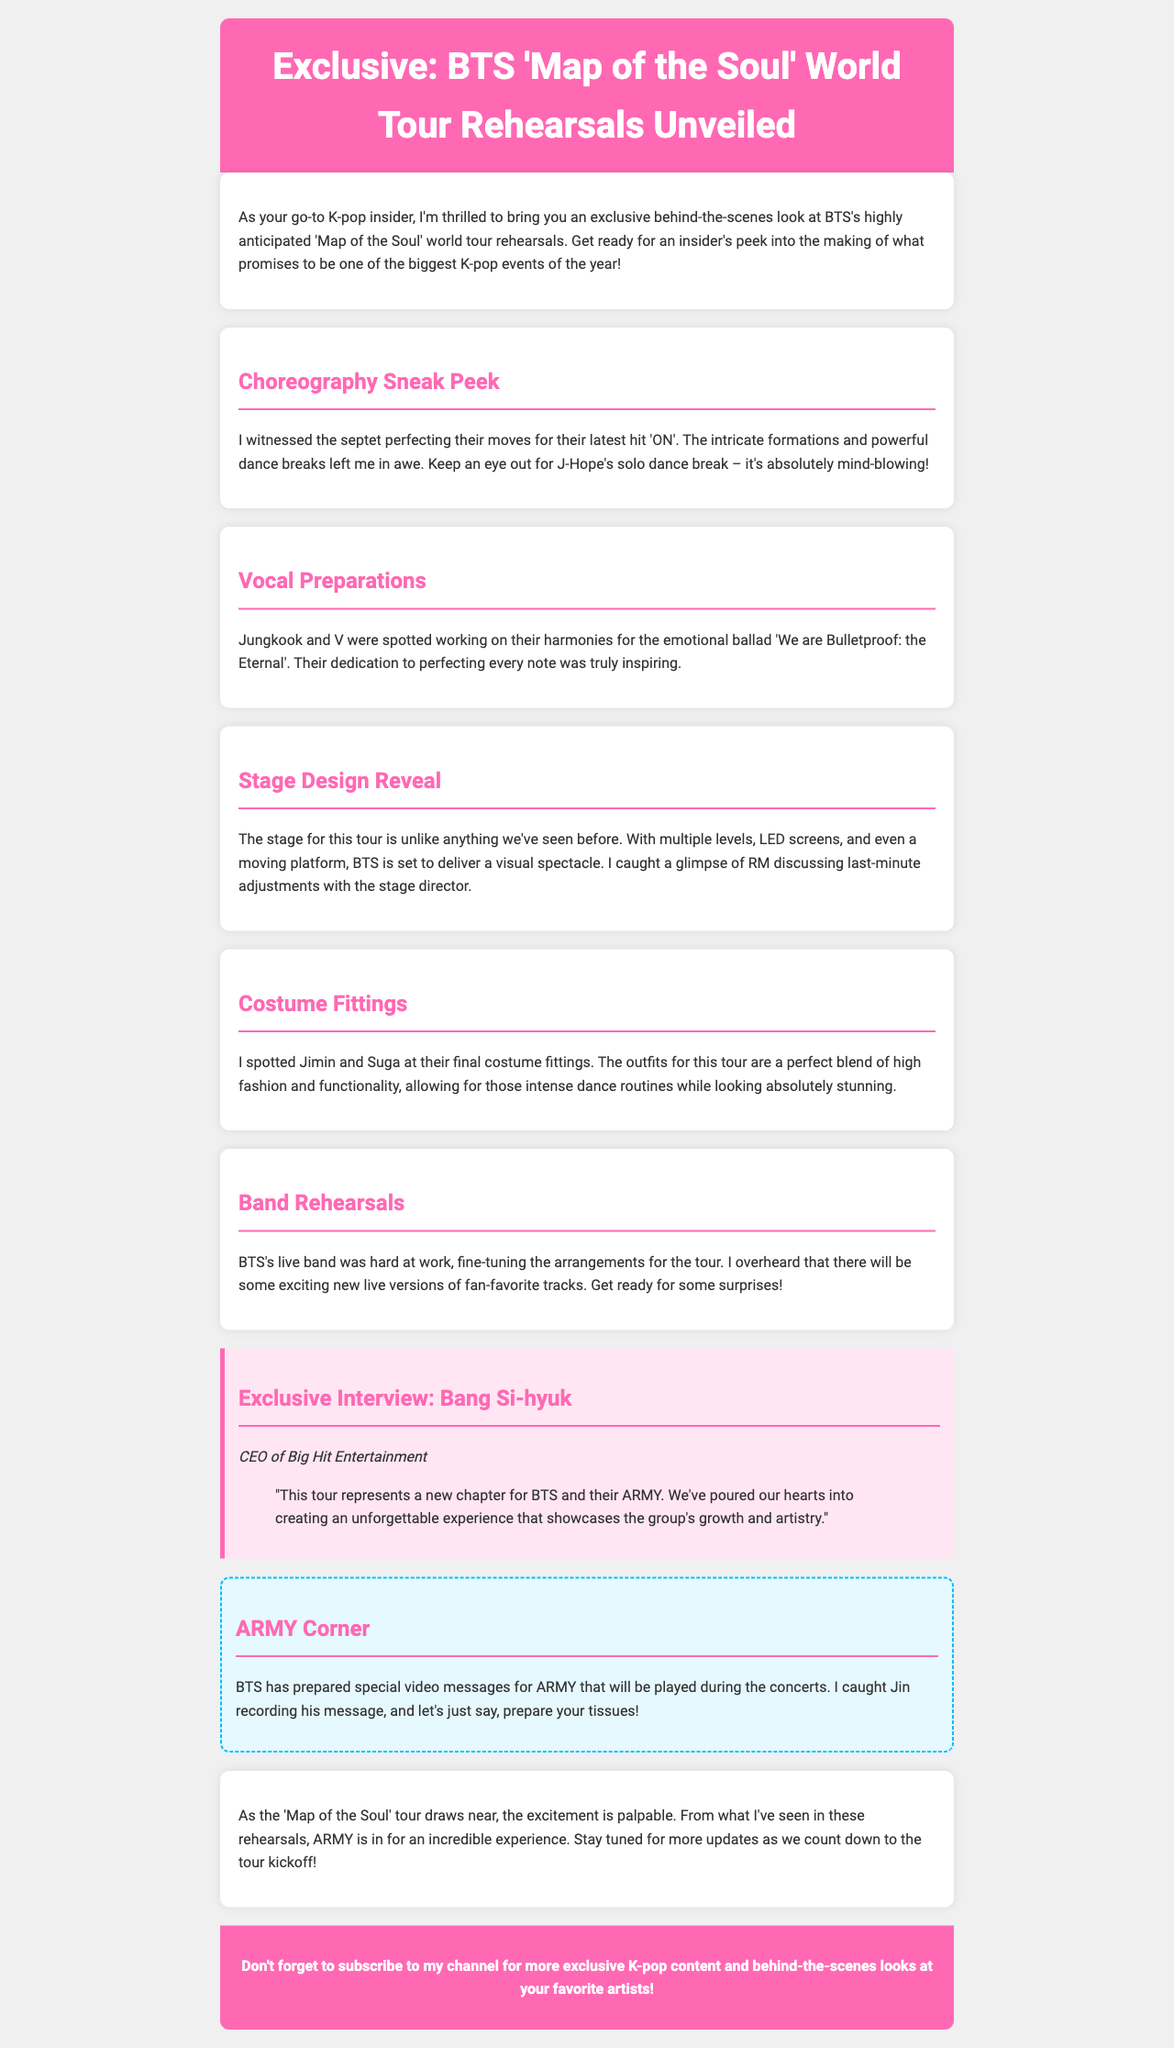What is the title of the newsletter? The title of the newsletter is explicitly stated at the beginning.
Answer: Exclusive: BTS 'Map of the Soul' World Tour Rehearsals Who is the interviewee in the exclusive interview section? The document mentions the person interviewed in the exclusive interview section.
Answer: Bang Si-hyuk What song are Jungkook and V working on harmonies for? The document specifies the song for which Jungkook and V were seen working on harmonies.
Answer: We are Bulletproof: the Eternal What significant feature is highlighted in the stage design reveal? The document describes a unique characteristic of the stage for the tour.
Answer: Multiple levels How many main sections are presented in the newsletter? The number of main topic sections can be counted from the document.
Answer: Five What is the name of the member seen recording a video message for ARMY? The document identifies a specific member recording a message for the fans.
Answer: Jin What color are the accents in the newsletter header? The document describes the visual design elements, including colors used in the header.
Answer: Pink What type of dance routine is mentioned for J-Hope? The content discusses a specific moment involving a member's performance.
Answer: Solo dance break 